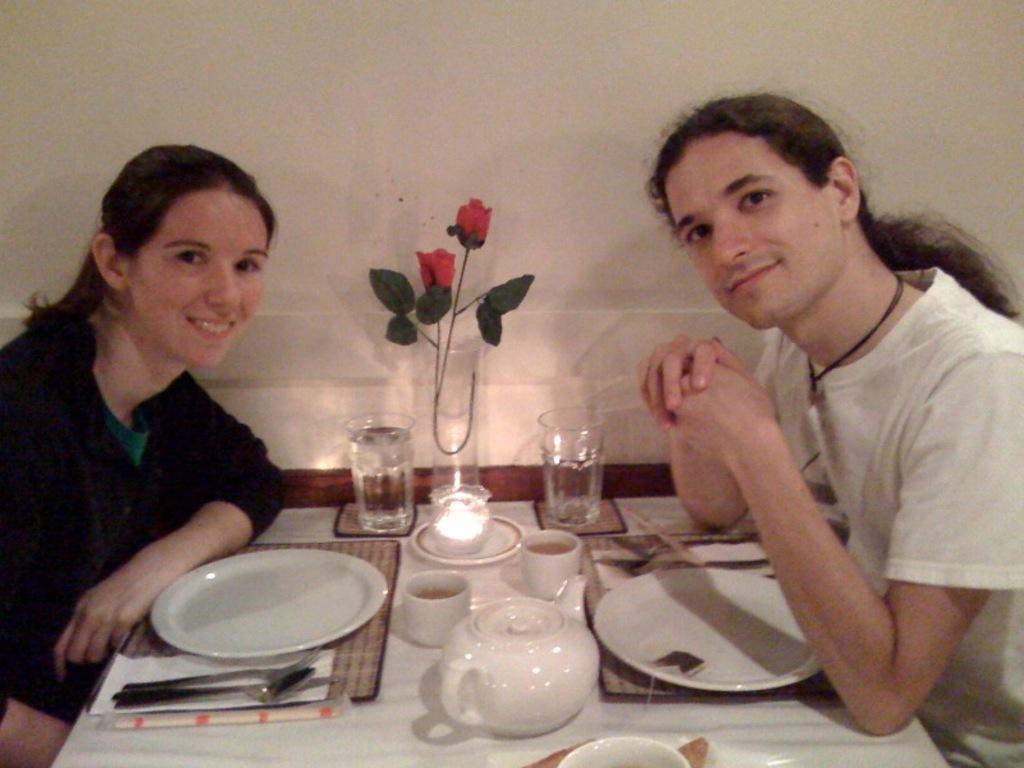In one or two sentences, can you explain what this image depicts? In this image I can see a person wearing black dress and a person wearing white dress are sitting on chair on the either sides of the table. On the table I can see few plates, few spoons, few tissue papers, few glasses and two flowers which are red in color. In the background I can see the white colored wall. 